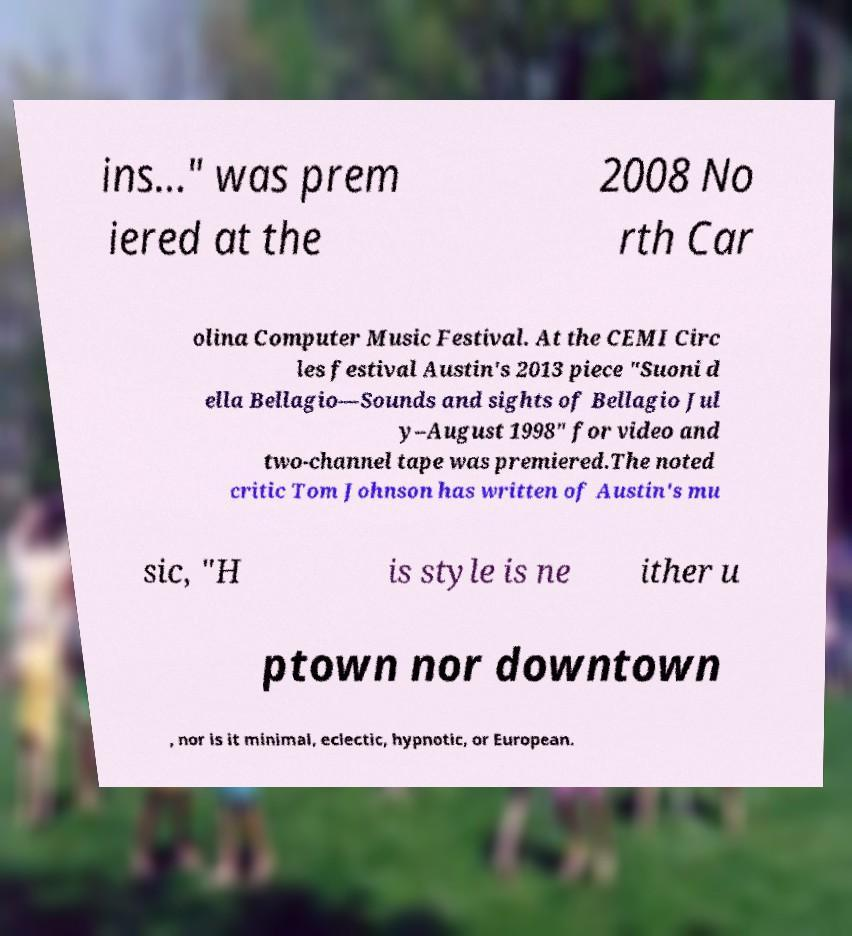Please identify and transcribe the text found in this image. ins..." was prem iered at the 2008 No rth Car olina Computer Music Festival. At the CEMI Circ les festival Austin's 2013 piece "Suoni d ella Bellagio—Sounds and sights of Bellagio Jul y–August 1998" for video and two-channel tape was premiered.The noted critic Tom Johnson has written of Austin's mu sic, "H is style is ne ither u ptown nor downtown , nor is it minimal, eclectic, hypnotic, or European. 